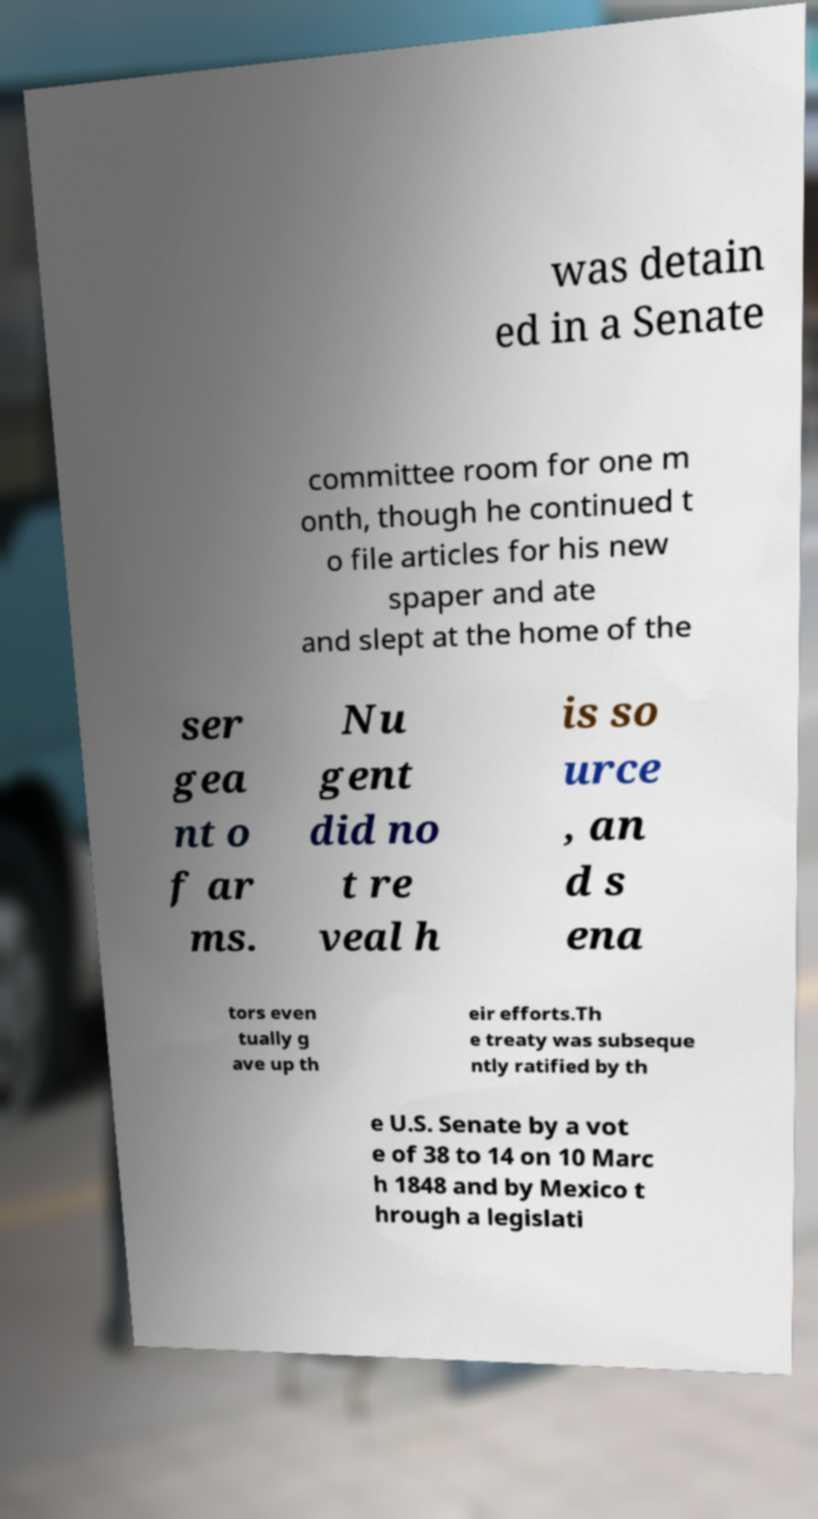Please identify and transcribe the text found in this image. was detain ed in a Senate committee room for one m onth, though he continued t o file articles for his new spaper and ate and slept at the home of the ser gea nt o f ar ms. Nu gent did no t re veal h is so urce , an d s ena tors even tually g ave up th eir efforts.Th e treaty was subseque ntly ratified by th e U.S. Senate by a vot e of 38 to 14 on 10 Marc h 1848 and by Mexico t hrough a legislati 